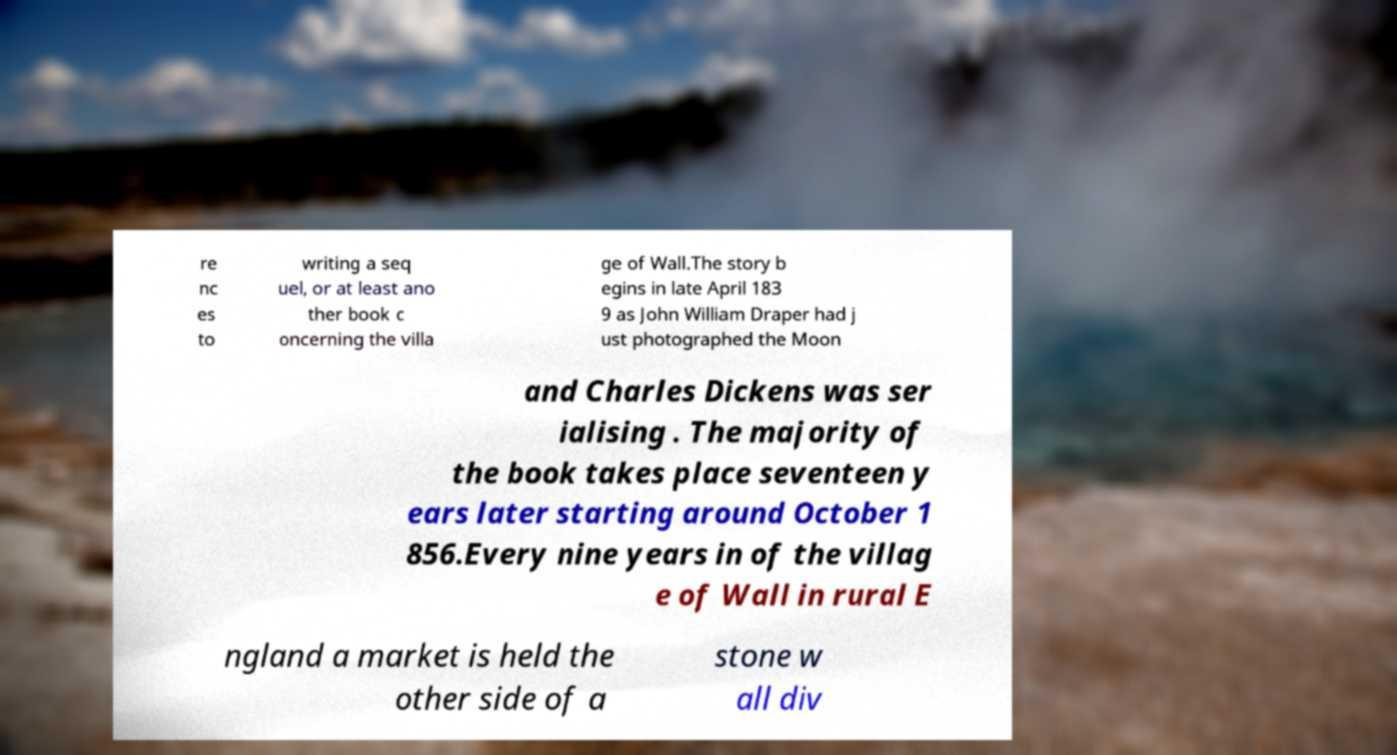What messages or text are displayed in this image? I need them in a readable, typed format. re nc es to writing a seq uel, or at least ano ther book c oncerning the villa ge of Wall.The story b egins in late April 183 9 as John William Draper had j ust photographed the Moon and Charles Dickens was ser ialising . The majority of the book takes place seventeen y ears later starting around October 1 856.Every nine years in of the villag e of Wall in rural E ngland a market is held the other side of a stone w all div 